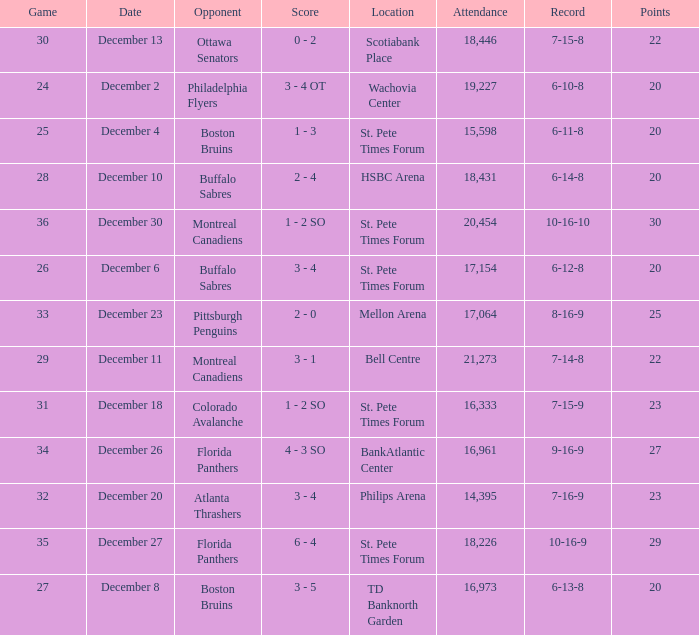What game has a 6-12-8 record? 26.0. 